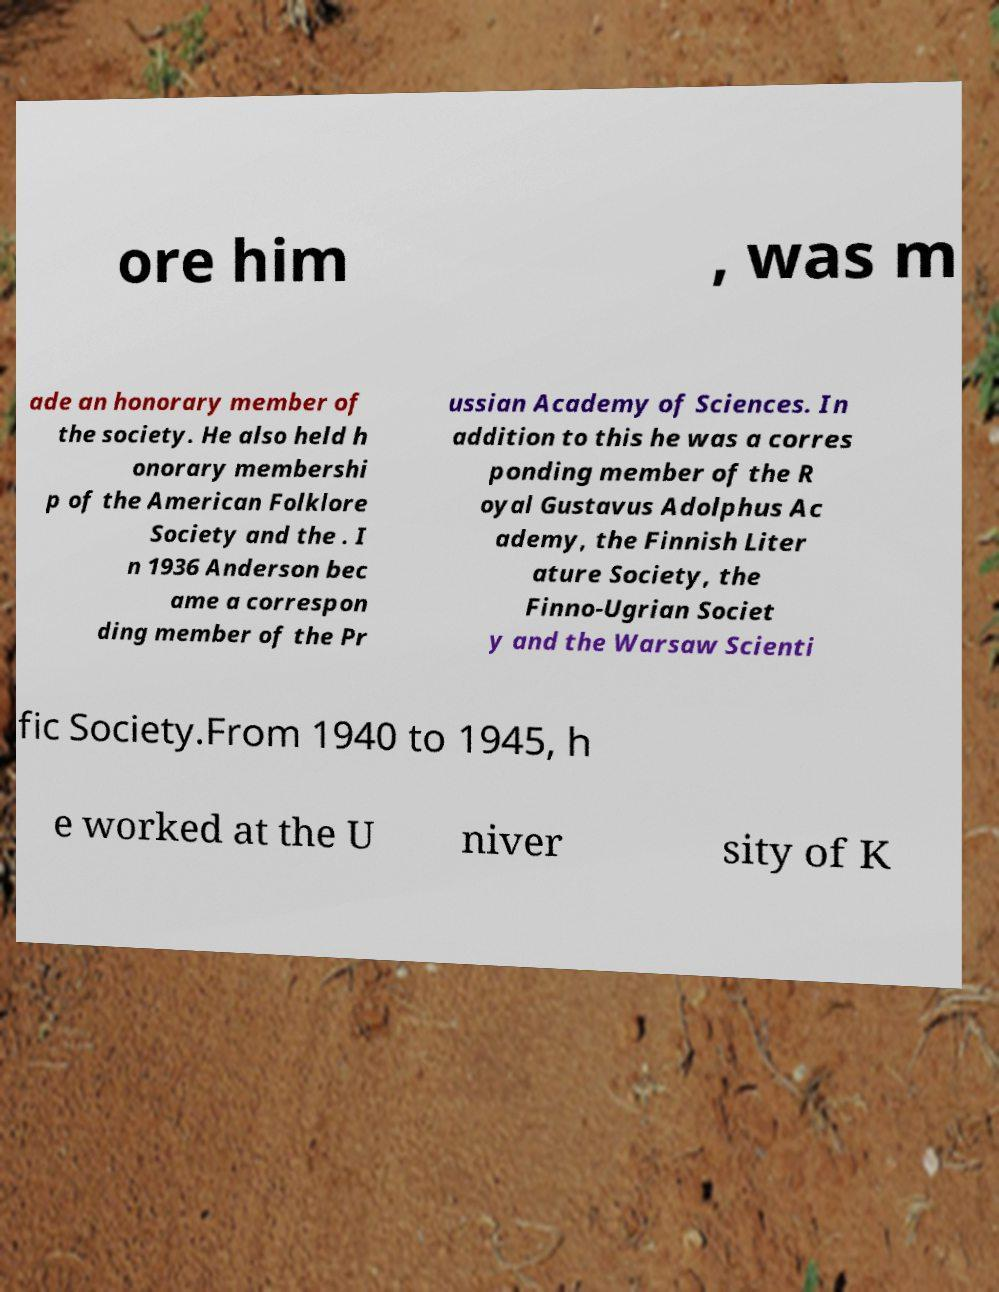Could you assist in decoding the text presented in this image and type it out clearly? ore him , was m ade an honorary member of the society. He also held h onorary membershi p of the American Folklore Society and the . I n 1936 Anderson bec ame a correspon ding member of the Pr ussian Academy of Sciences. In addition to this he was a corres ponding member of the R oyal Gustavus Adolphus Ac ademy, the Finnish Liter ature Society, the Finno-Ugrian Societ y and the Warsaw Scienti fic Society.From 1940 to 1945, h e worked at the U niver sity of K 